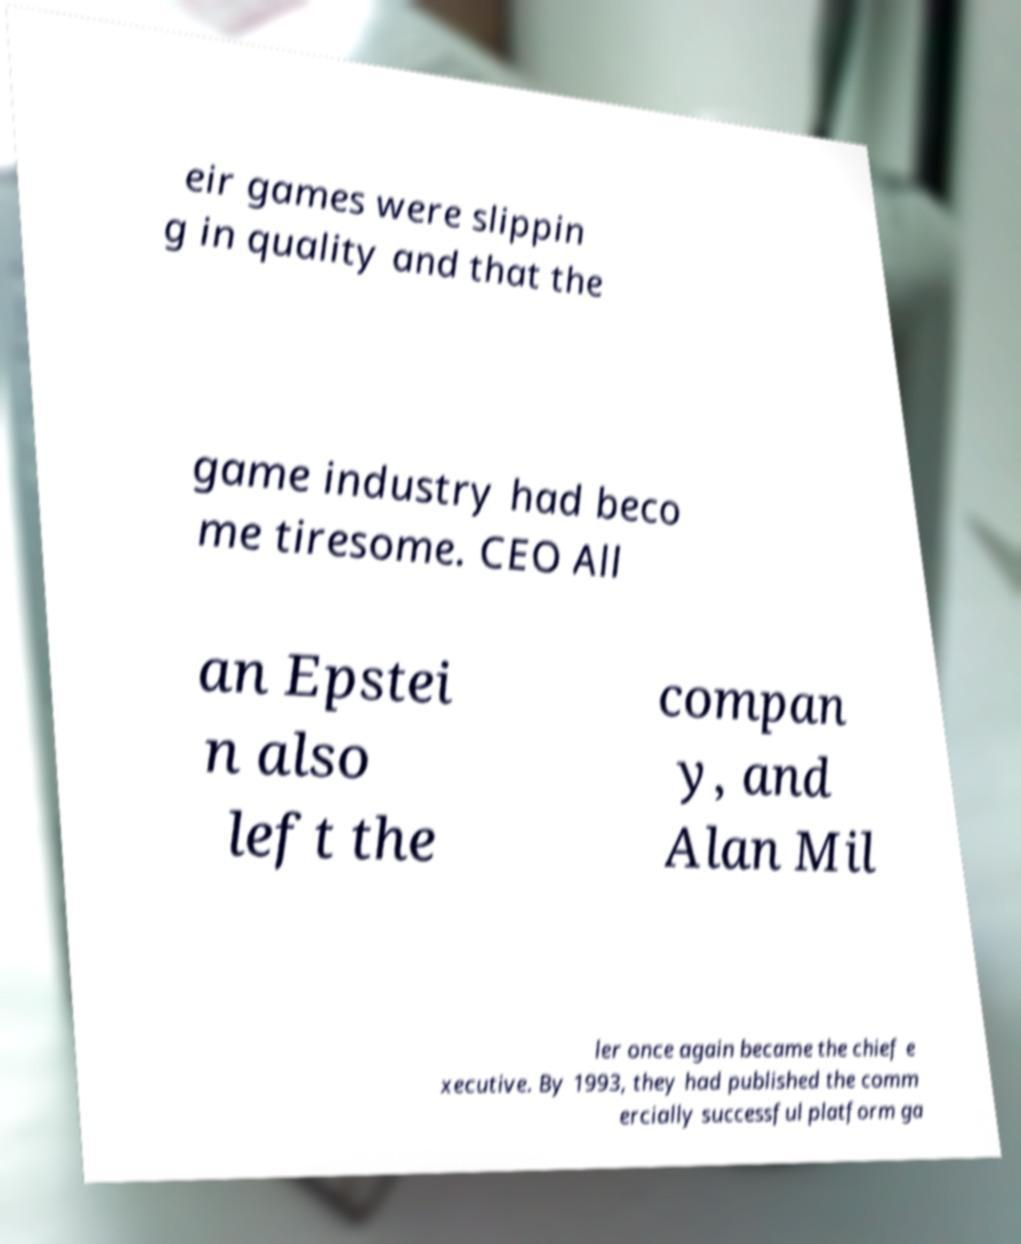What messages or text are displayed in this image? I need them in a readable, typed format. eir games were slippin g in quality and that the game industry had beco me tiresome. CEO All an Epstei n also left the compan y, and Alan Mil ler once again became the chief e xecutive. By 1993, they had published the comm ercially successful platform ga 